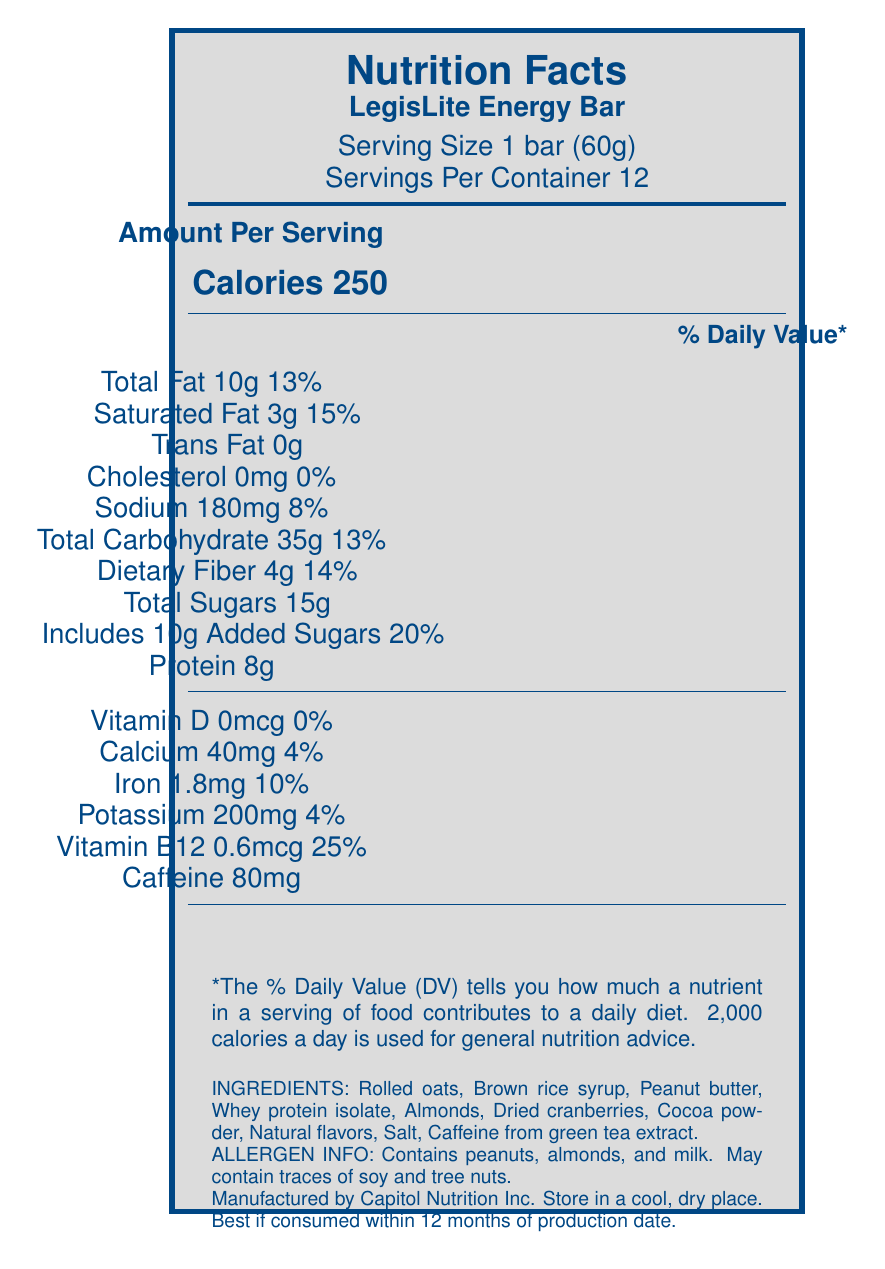What is the serving size of the LegisLite Energy Bar? The serving size is directly stated below the product name on the label: "Serving Size 1 bar (60g)".
Answer: 1 bar (60g) How many calories are in one serving of the LegisLite Energy Bar? The calories per serving are displayed prominently in the center of the label, mentioned as "Calories 250".
Answer: 250 What percentage of the daily value for saturated fat does one serving of the LegisLite Energy Bar provide? The percentage daily value for saturated fat is listed next to the amount of saturated fat, which is 3g, followed by "15%".
Answer: 15% List three ingredients of the LegisLite Energy Bar. The ingredients list at the bottom of the label includes these among others: "Rolled oats, Brown rice syrup, Peanut butter, Whey protein isolate, Almonds, Dried cranberries, Cocoa powder, Natural flavors, Salt, Caffeine from green tea extract".
Answer: Rolled oats, Brown rice syrup, Peanut butter What is the amount of dietary fiber in one serving of the LegisLite Energy Bar? The amount of dietary fiber per serving is stated as "4g" in the Total Carbohydrate section.
Answer: 4g How much caffeine does one serving of the LegisLite Energy Bar contain? The caffeine content is listed near the end of the nutrient section as "Caffeine 80mg".
Answer: 80mg What is the total fat content per serving? A. 5g B. 10g C. 15g D. 20g The total fat content is listed as "Total Fat 10g" on the label.
Answer: B Which nutrient has the highest percentage daily value in one serving? A. Saturated Fat B. Added Sugars C. Vitamin B12 Vitamin B12 has the highest percentage daily value of 25%, compared to Saturated Fat at 15% and Added Sugars at 20%.
Answer: C Does the LegisLite Energy Bar contain any artificial preservatives? The marketing claims section states "No artificial preservatives".
Answer: No Summarize the main idea of the LegisLite Energy Bar's nutrition label. The summary includes the calorie count, benefits, absence of artificial preservatives, and the purpose of the bar as designed for long legislative sessions.
Answer: The LegisLite Energy Bar is an energy snack designed for sustained energy during long legislative sessions, featuring 250 calories per serving, high protein, and significant amounts of dietary fiber and vitamin B12. It contains no artificial preservatives and provides essential nutrients to support cognitive function. What is the production date of the LegisLite Energy Bar? The label specifies storage and expiration details but does not provide the production date.
Answer: Not enough information How many servings are in one container of the LegisLite Energy Bar? The servings per container are stated as "Servings Per Container 12" directly below the serving size.
Answer: 12 